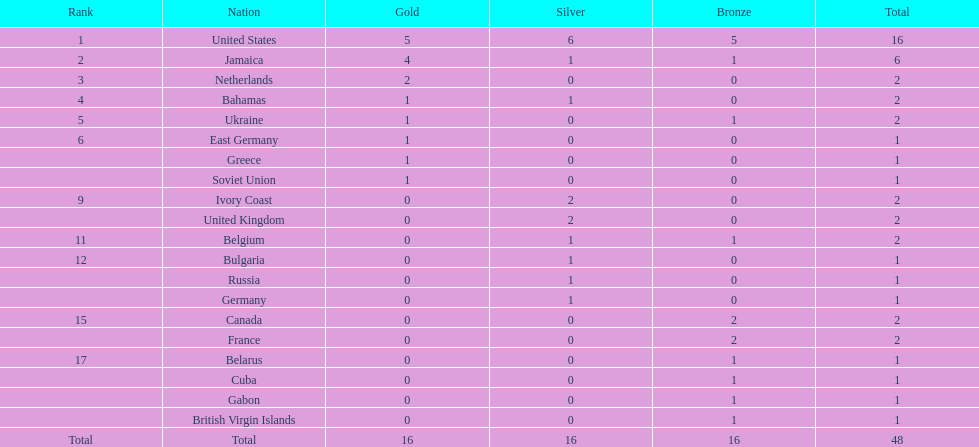How many countries claimed no gold medals? 12. 